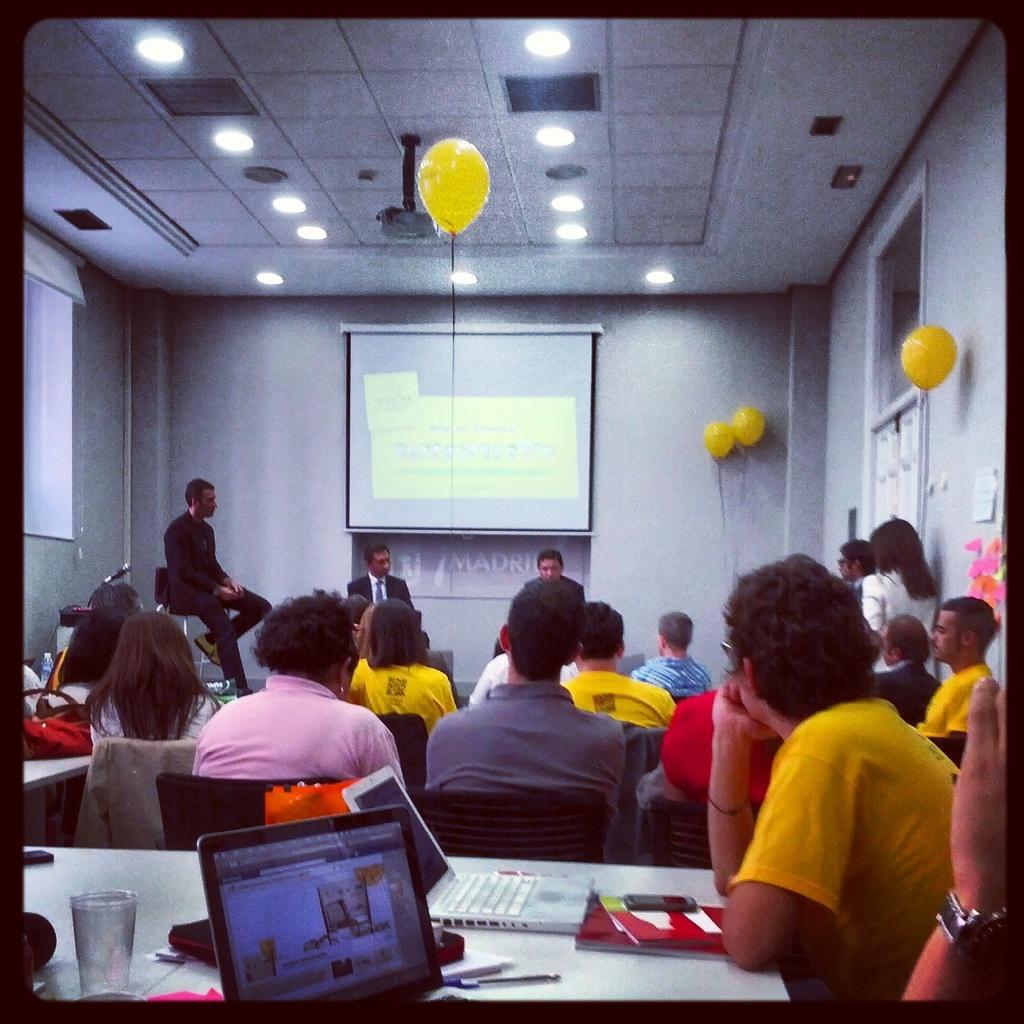How would you summarize this image in a sentence or two? In this image few persons are sitting on the chairs. Bottom of the image there is a table having few laptops, glass, mobile, books and few objects on it. Beside it a person is sitting. Few persons are sitting on the stage. Background there is wall having few balloons attached to it. There is a screen. Middle of the image there is a balloon. Top of the image there are few lights and projector attached to the roof. 